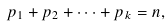<formula> <loc_0><loc_0><loc_500><loc_500>p _ { 1 } + p _ { 2 } + \dots + p _ { k } = n ,</formula> 